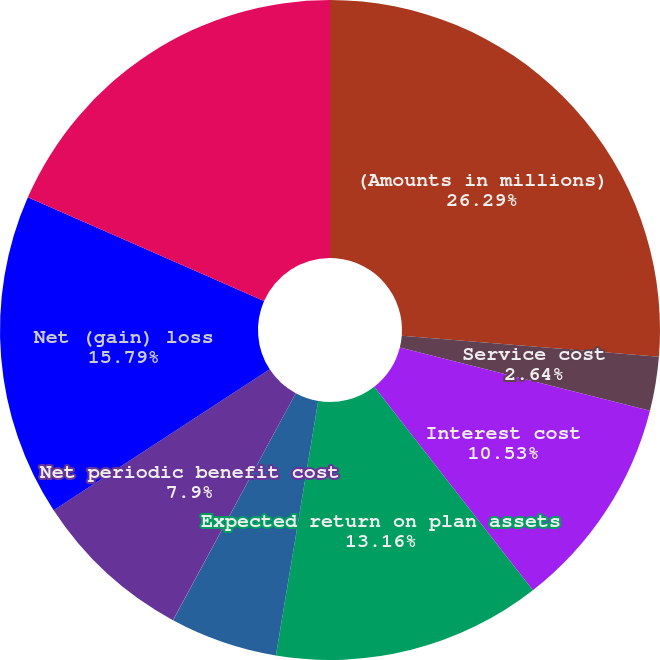Convert chart. <chart><loc_0><loc_0><loc_500><loc_500><pie_chart><fcel>(Amounts in millions)<fcel>Service cost<fcel>Interest cost<fcel>Expected return on plan assets<fcel>Amortization of unrecognized<fcel>Amortization of prior service<fcel>Net periodic benefit cost<fcel>Net (gain) loss<fcel>Total recognized in OCI<nl><fcel>26.3%<fcel>2.64%<fcel>10.53%<fcel>13.16%<fcel>5.27%<fcel>0.01%<fcel>7.9%<fcel>15.79%<fcel>18.42%<nl></chart> 